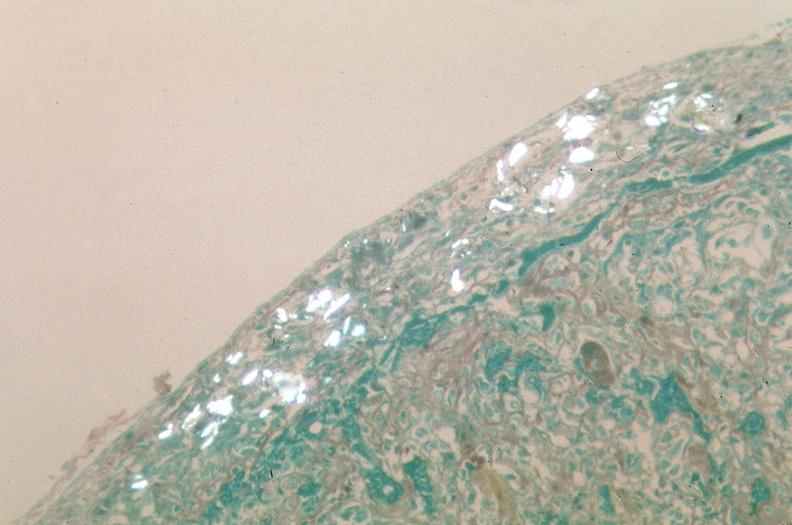was talc used to sclerose emphysematous lung, alpha-1 antitrypsin deficiency?
Answer the question using a single word or phrase. Yes 